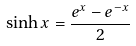<formula> <loc_0><loc_0><loc_500><loc_500>\sinh x = \frac { e ^ { x } - e ^ { - x } } { 2 }</formula> 